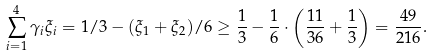Convert formula to latex. <formula><loc_0><loc_0><loc_500><loc_500>\sum _ { i = 1 } ^ { 4 } \gamma _ { i } \xi _ { i } = 1 / 3 - ( \xi _ { 1 } + \xi _ { 2 } ) / 6 \geq \frac { 1 } { 3 } - \frac { 1 } { 6 } \cdot \left ( \frac { 1 1 } { 3 6 } + \frac { 1 } { 3 } \right ) = \frac { 4 9 } { 2 1 6 } .</formula> 